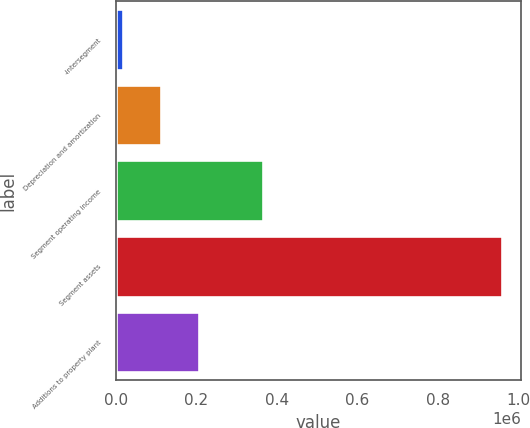Convert chart to OTSL. <chart><loc_0><loc_0><loc_500><loc_500><bar_chart><fcel>-intersegment<fcel>Depreciation and amortization<fcel>Segment operating income<fcel>Segment assets<fcel>Additions to property plant<nl><fcel>18390<fcel>112307<fcel>365267<fcel>957559<fcel>206224<nl></chart> 